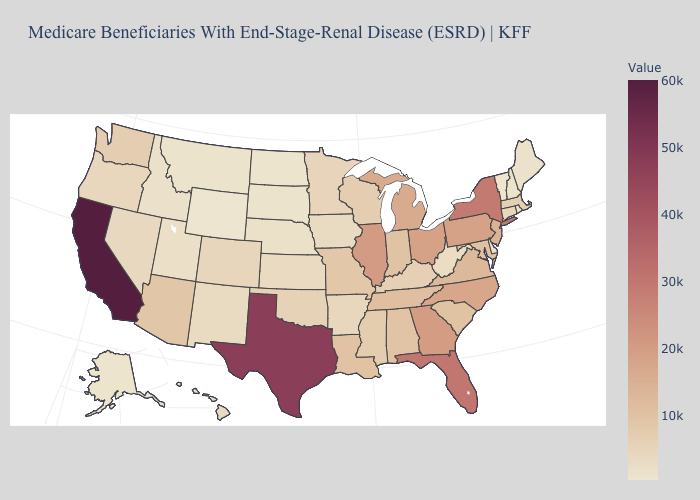Among the states that border Georgia , which have the lowest value?
Write a very short answer. Alabama. Does California have the highest value in the USA?
Be succinct. Yes. Among the states that border Tennessee , which have the highest value?
Short answer required. Georgia. Among the states that border Mississippi , does Tennessee have the highest value?
Keep it brief. Yes. Which states have the highest value in the USA?
Answer briefly. California. Which states have the lowest value in the USA?
Answer briefly. Wyoming. 